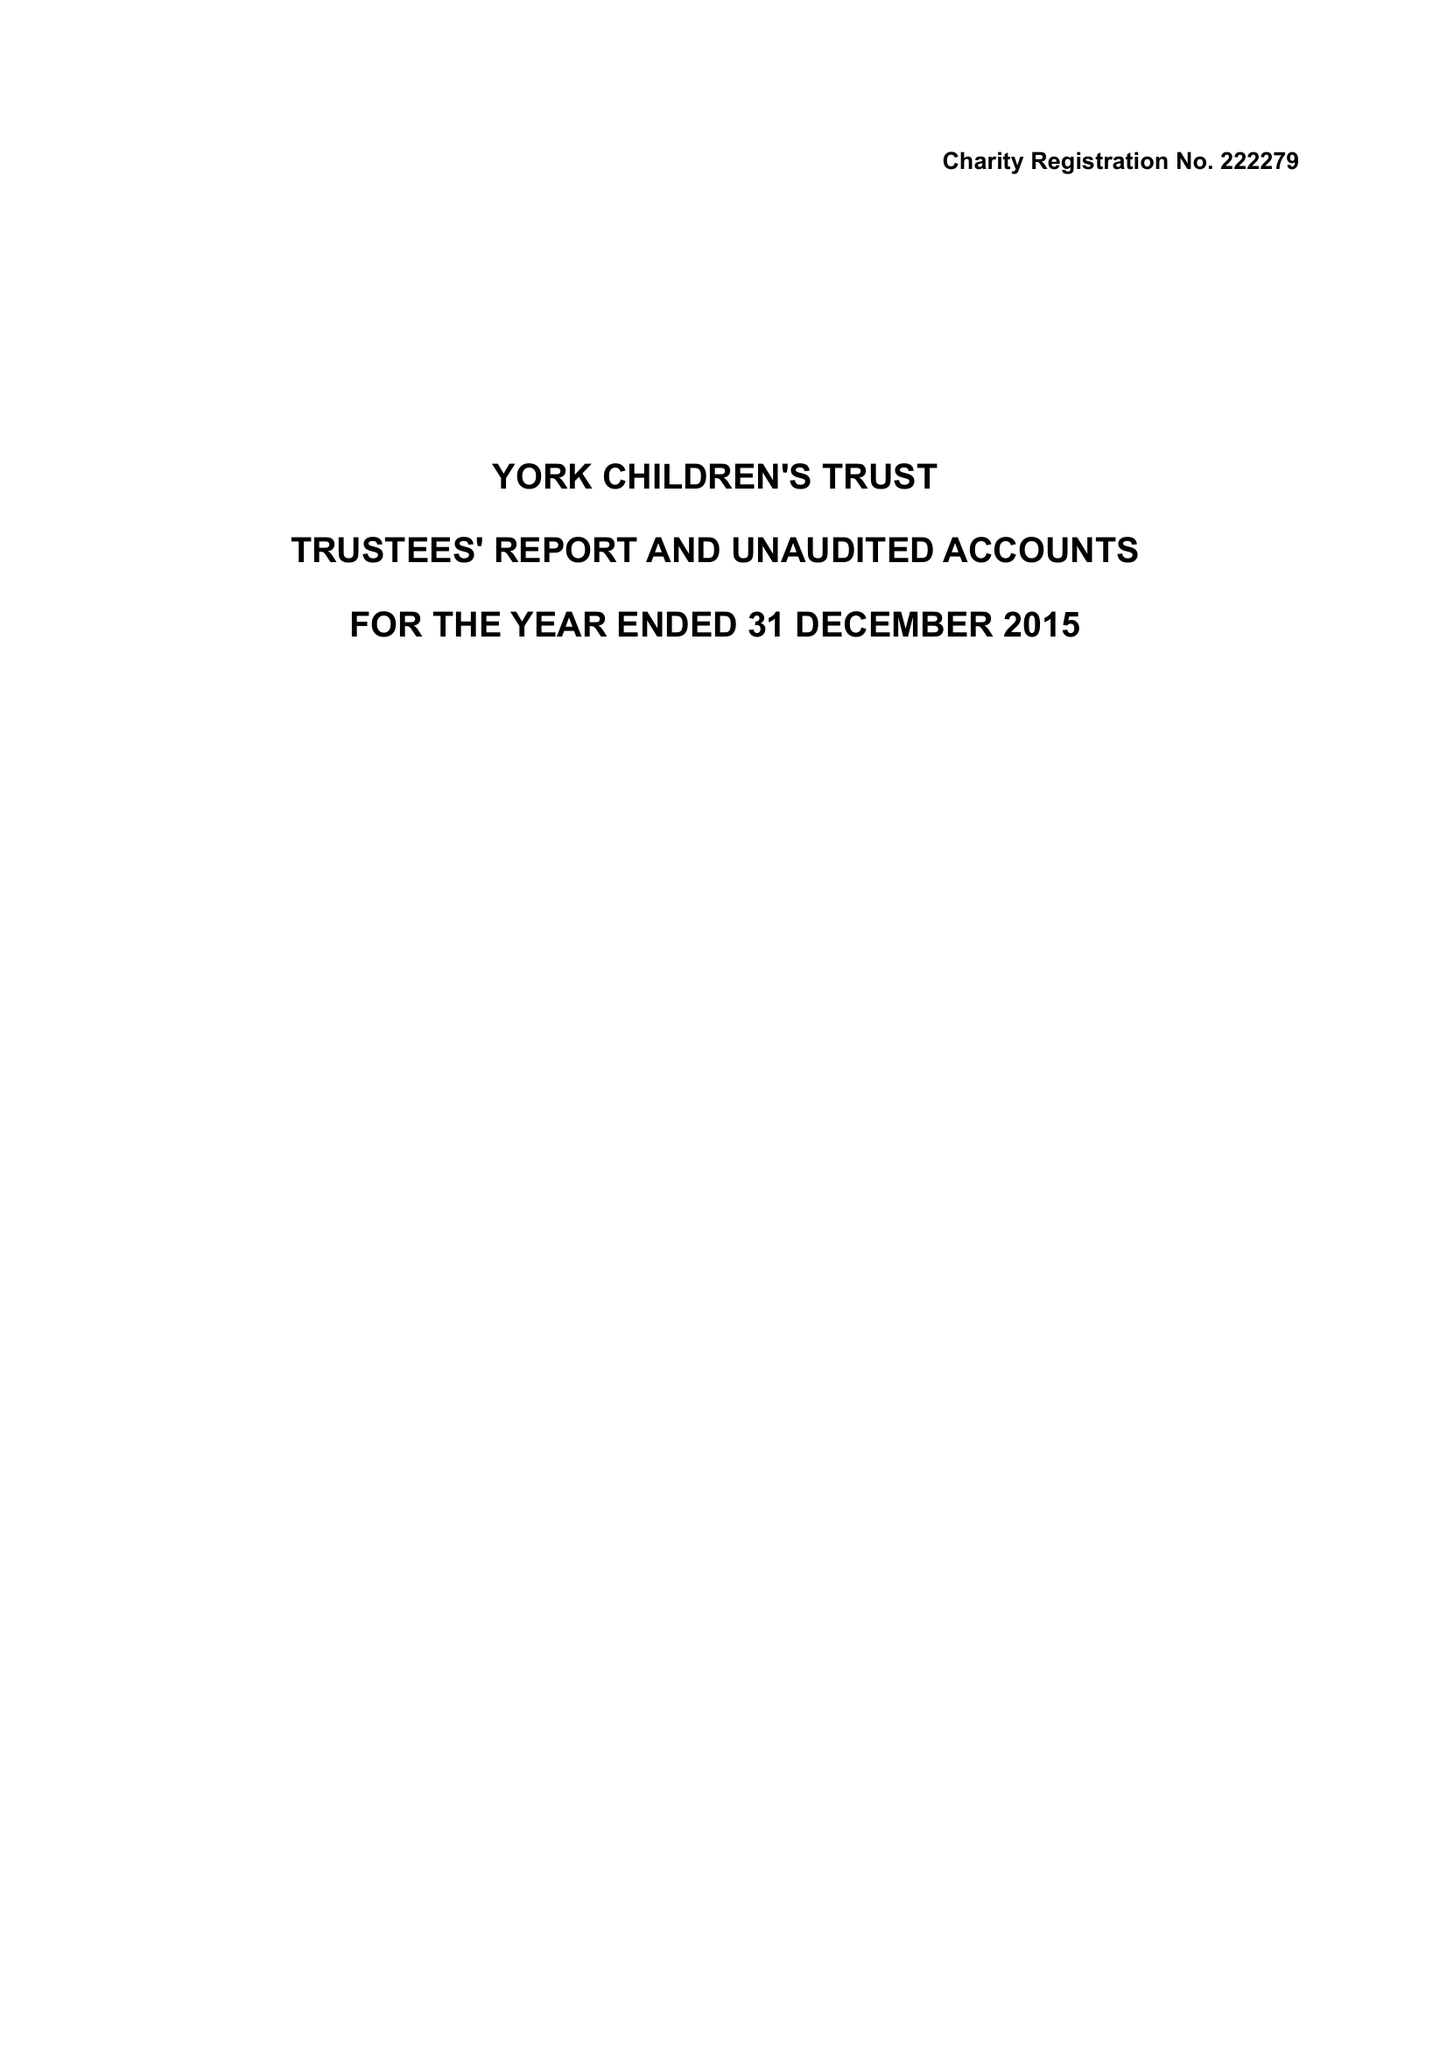What is the value for the charity_number?
Answer the question using a single word or phrase. 222279 